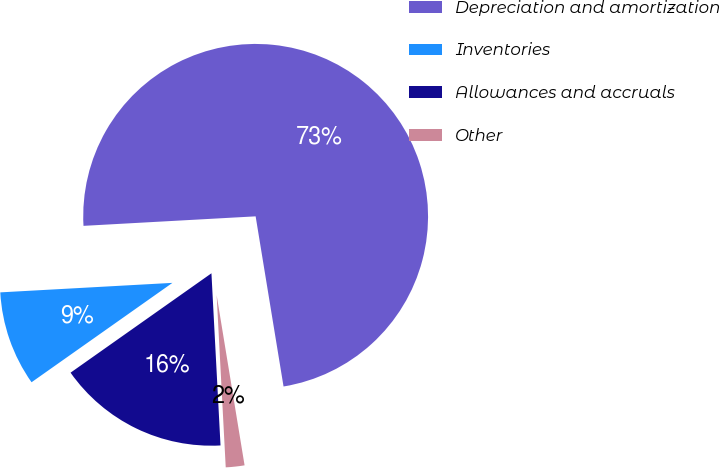Convert chart. <chart><loc_0><loc_0><loc_500><loc_500><pie_chart><fcel>Depreciation and amortization<fcel>Inventories<fcel>Allowances and accruals<fcel>Other<nl><fcel>73.29%<fcel>8.9%<fcel>16.06%<fcel>1.75%<nl></chart> 